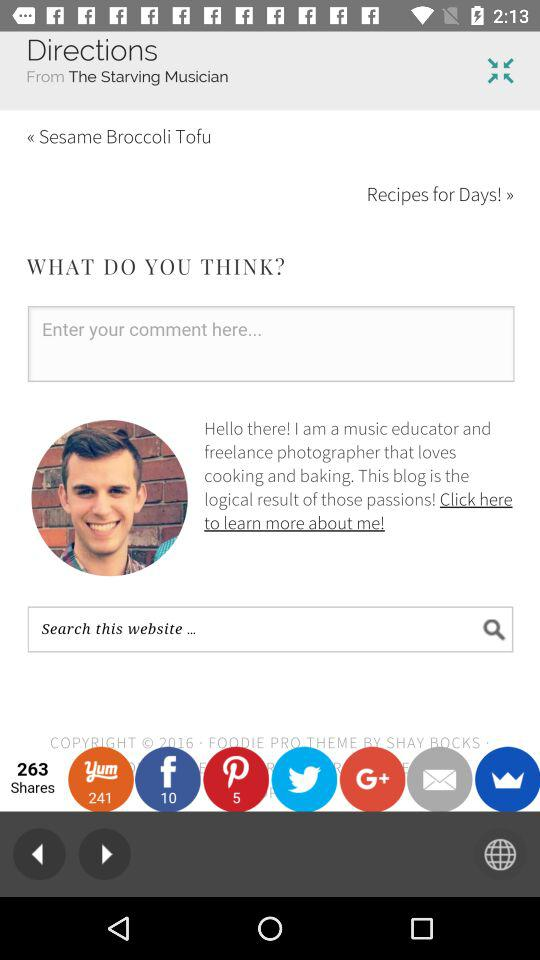How many shares are there? There are 263 shares. 